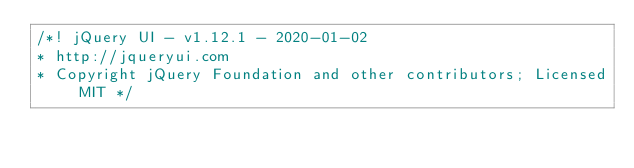<code> <loc_0><loc_0><loc_500><loc_500><_CSS_>/*! jQuery UI - v1.12.1 - 2020-01-02
* http://jqueryui.com
* Copyright jQuery Foundation and other contributors; Licensed MIT */
</code> 